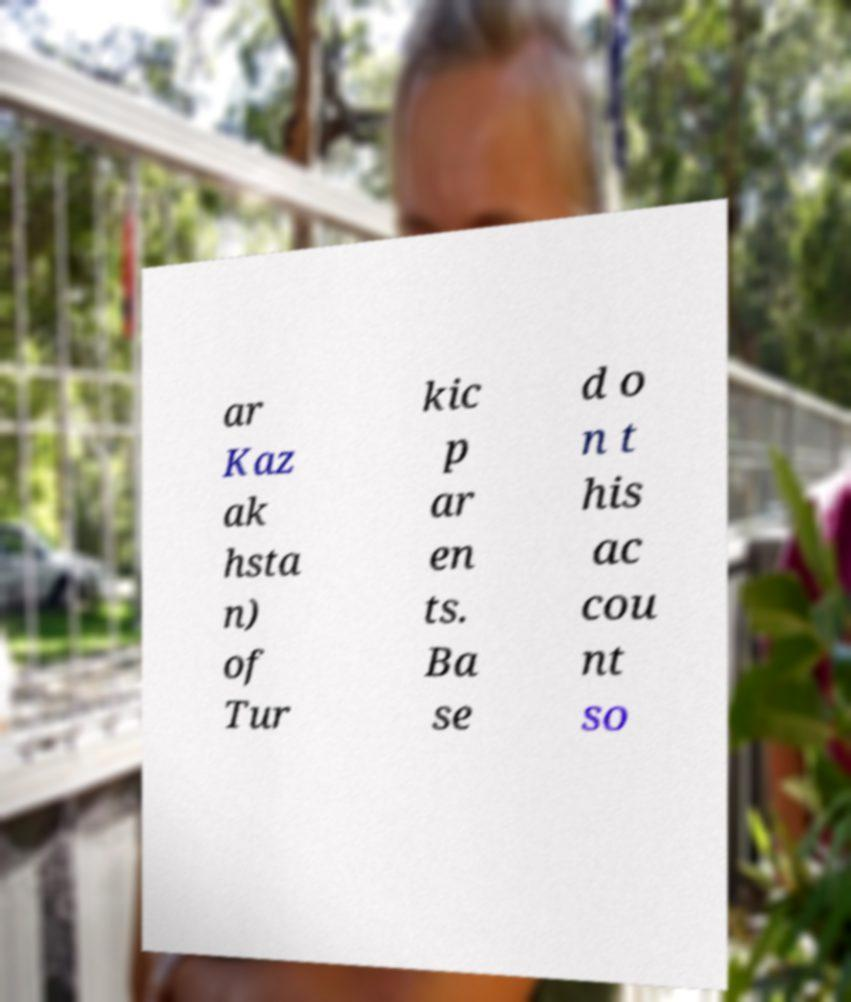I need the written content from this picture converted into text. Can you do that? ar Kaz ak hsta n) of Tur kic p ar en ts. Ba se d o n t his ac cou nt so 